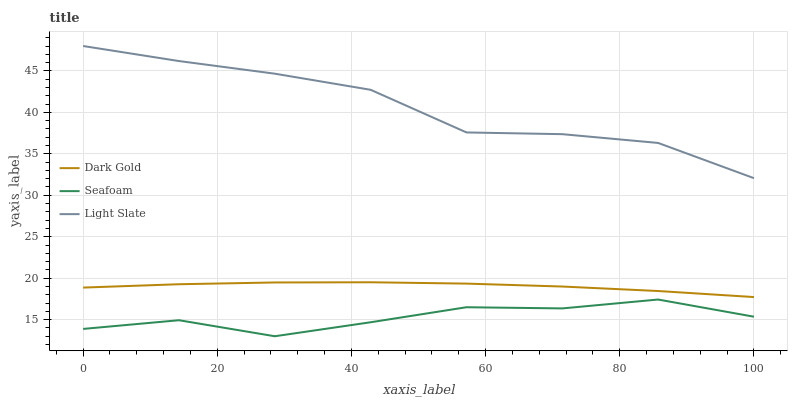Does Seafoam have the minimum area under the curve?
Answer yes or no. Yes. Does Light Slate have the maximum area under the curve?
Answer yes or no. Yes. Does Dark Gold have the minimum area under the curve?
Answer yes or no. No. Does Dark Gold have the maximum area under the curve?
Answer yes or no. No. Is Dark Gold the smoothest?
Answer yes or no. Yes. Is Seafoam the roughest?
Answer yes or no. Yes. Is Seafoam the smoothest?
Answer yes or no. No. Is Dark Gold the roughest?
Answer yes or no. No. Does Seafoam have the lowest value?
Answer yes or no. Yes. Does Dark Gold have the lowest value?
Answer yes or no. No. Does Light Slate have the highest value?
Answer yes or no. Yes. Does Dark Gold have the highest value?
Answer yes or no. No. Is Seafoam less than Dark Gold?
Answer yes or no. Yes. Is Dark Gold greater than Seafoam?
Answer yes or no. Yes. Does Seafoam intersect Dark Gold?
Answer yes or no. No. 